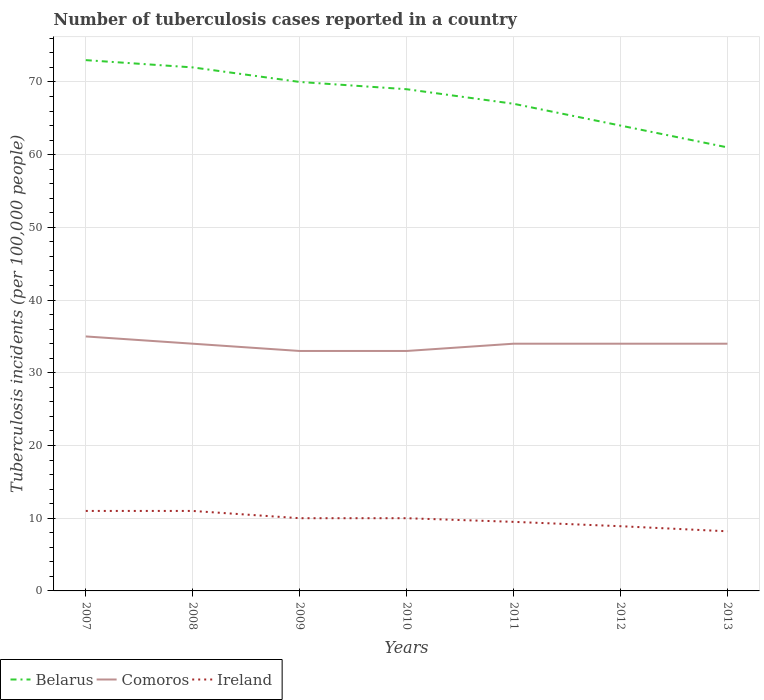Across all years, what is the maximum number of tuberculosis cases reported in in Belarus?
Ensure brevity in your answer.  61. What is the total number of tuberculosis cases reported in in Ireland in the graph?
Give a very brief answer. 2.1. What is the difference between the highest and the second highest number of tuberculosis cases reported in in Belarus?
Provide a succinct answer. 12. How many lines are there?
Provide a succinct answer. 3. How many years are there in the graph?
Make the answer very short. 7. What is the difference between two consecutive major ticks on the Y-axis?
Make the answer very short. 10. Are the values on the major ticks of Y-axis written in scientific E-notation?
Provide a succinct answer. No. Does the graph contain grids?
Keep it short and to the point. Yes. How are the legend labels stacked?
Offer a terse response. Horizontal. What is the title of the graph?
Your answer should be very brief. Number of tuberculosis cases reported in a country. What is the label or title of the Y-axis?
Your response must be concise. Tuberculosis incidents (per 100,0 people). What is the Tuberculosis incidents (per 100,000 people) of Ireland in 2007?
Your response must be concise. 11. What is the Tuberculosis incidents (per 100,000 people) in Ireland in 2008?
Your answer should be very brief. 11. What is the Tuberculosis incidents (per 100,000 people) in Belarus in 2009?
Keep it short and to the point. 70. What is the Tuberculosis incidents (per 100,000 people) of Comoros in 2011?
Make the answer very short. 34. What is the Tuberculosis incidents (per 100,000 people) in Ireland in 2012?
Provide a short and direct response. 8.9. What is the Tuberculosis incidents (per 100,000 people) in Comoros in 2013?
Offer a very short reply. 34. What is the Tuberculosis incidents (per 100,000 people) in Ireland in 2013?
Provide a succinct answer. 8.2. Across all years, what is the maximum Tuberculosis incidents (per 100,000 people) in Belarus?
Offer a terse response. 73. Across all years, what is the maximum Tuberculosis incidents (per 100,000 people) of Comoros?
Your answer should be compact. 35. Across all years, what is the minimum Tuberculosis incidents (per 100,000 people) of Comoros?
Offer a terse response. 33. What is the total Tuberculosis incidents (per 100,000 people) of Belarus in the graph?
Provide a short and direct response. 476. What is the total Tuberculosis incidents (per 100,000 people) in Comoros in the graph?
Keep it short and to the point. 237. What is the total Tuberculosis incidents (per 100,000 people) of Ireland in the graph?
Ensure brevity in your answer.  68.6. What is the difference between the Tuberculosis incidents (per 100,000 people) of Belarus in 2007 and that in 2008?
Keep it short and to the point. 1. What is the difference between the Tuberculosis incidents (per 100,000 people) of Ireland in 2007 and that in 2008?
Your answer should be compact. 0. What is the difference between the Tuberculosis incidents (per 100,000 people) of Belarus in 2007 and that in 2009?
Offer a terse response. 3. What is the difference between the Tuberculosis incidents (per 100,000 people) in Comoros in 2007 and that in 2009?
Your response must be concise. 2. What is the difference between the Tuberculosis incidents (per 100,000 people) in Ireland in 2007 and that in 2009?
Your answer should be very brief. 1. What is the difference between the Tuberculosis incidents (per 100,000 people) in Belarus in 2007 and that in 2010?
Your answer should be very brief. 4. What is the difference between the Tuberculosis incidents (per 100,000 people) of Comoros in 2007 and that in 2010?
Your answer should be compact. 2. What is the difference between the Tuberculosis incidents (per 100,000 people) of Comoros in 2007 and that in 2011?
Give a very brief answer. 1. What is the difference between the Tuberculosis incidents (per 100,000 people) of Ireland in 2007 and that in 2011?
Make the answer very short. 1.5. What is the difference between the Tuberculosis incidents (per 100,000 people) of Belarus in 2007 and that in 2012?
Provide a short and direct response. 9. What is the difference between the Tuberculosis incidents (per 100,000 people) of Belarus in 2007 and that in 2013?
Make the answer very short. 12. What is the difference between the Tuberculosis incidents (per 100,000 people) of Ireland in 2007 and that in 2013?
Keep it short and to the point. 2.8. What is the difference between the Tuberculosis incidents (per 100,000 people) of Comoros in 2008 and that in 2009?
Offer a terse response. 1. What is the difference between the Tuberculosis incidents (per 100,000 people) of Ireland in 2008 and that in 2009?
Give a very brief answer. 1. What is the difference between the Tuberculosis incidents (per 100,000 people) in Belarus in 2008 and that in 2010?
Provide a succinct answer. 3. What is the difference between the Tuberculosis incidents (per 100,000 people) of Comoros in 2008 and that in 2010?
Offer a terse response. 1. What is the difference between the Tuberculosis incidents (per 100,000 people) of Ireland in 2008 and that in 2011?
Your answer should be very brief. 1.5. What is the difference between the Tuberculosis incidents (per 100,000 people) in Belarus in 2008 and that in 2012?
Give a very brief answer. 8. What is the difference between the Tuberculosis incidents (per 100,000 people) in Belarus in 2008 and that in 2013?
Offer a very short reply. 11. What is the difference between the Tuberculosis incidents (per 100,000 people) in Ireland in 2008 and that in 2013?
Your response must be concise. 2.8. What is the difference between the Tuberculosis incidents (per 100,000 people) in Comoros in 2009 and that in 2010?
Provide a succinct answer. 0. What is the difference between the Tuberculosis incidents (per 100,000 people) in Belarus in 2009 and that in 2012?
Offer a terse response. 6. What is the difference between the Tuberculosis incidents (per 100,000 people) in Belarus in 2009 and that in 2013?
Your answer should be compact. 9. What is the difference between the Tuberculosis incidents (per 100,000 people) of Comoros in 2009 and that in 2013?
Offer a terse response. -1. What is the difference between the Tuberculosis incidents (per 100,000 people) in Ireland in 2009 and that in 2013?
Your answer should be compact. 1.8. What is the difference between the Tuberculosis incidents (per 100,000 people) of Belarus in 2010 and that in 2011?
Give a very brief answer. 2. What is the difference between the Tuberculosis incidents (per 100,000 people) in Comoros in 2010 and that in 2011?
Make the answer very short. -1. What is the difference between the Tuberculosis incidents (per 100,000 people) of Comoros in 2010 and that in 2012?
Your answer should be very brief. -1. What is the difference between the Tuberculosis incidents (per 100,000 people) in Comoros in 2011 and that in 2012?
Your answer should be compact. 0. What is the difference between the Tuberculosis incidents (per 100,000 people) in Ireland in 2011 and that in 2012?
Keep it short and to the point. 0.6. What is the difference between the Tuberculosis incidents (per 100,000 people) in Comoros in 2011 and that in 2013?
Give a very brief answer. 0. What is the difference between the Tuberculosis incidents (per 100,000 people) of Belarus in 2012 and that in 2013?
Provide a succinct answer. 3. What is the difference between the Tuberculosis incidents (per 100,000 people) in Ireland in 2012 and that in 2013?
Your answer should be very brief. 0.7. What is the difference between the Tuberculosis incidents (per 100,000 people) of Belarus in 2007 and the Tuberculosis incidents (per 100,000 people) of Comoros in 2008?
Make the answer very short. 39. What is the difference between the Tuberculosis incidents (per 100,000 people) of Comoros in 2007 and the Tuberculosis incidents (per 100,000 people) of Ireland in 2008?
Your answer should be very brief. 24. What is the difference between the Tuberculosis incidents (per 100,000 people) in Belarus in 2007 and the Tuberculosis incidents (per 100,000 people) in Comoros in 2009?
Ensure brevity in your answer.  40. What is the difference between the Tuberculosis incidents (per 100,000 people) in Comoros in 2007 and the Tuberculosis incidents (per 100,000 people) in Ireland in 2009?
Provide a succinct answer. 25. What is the difference between the Tuberculosis incidents (per 100,000 people) of Belarus in 2007 and the Tuberculosis incidents (per 100,000 people) of Comoros in 2010?
Offer a terse response. 40. What is the difference between the Tuberculosis incidents (per 100,000 people) of Comoros in 2007 and the Tuberculosis incidents (per 100,000 people) of Ireland in 2010?
Ensure brevity in your answer.  25. What is the difference between the Tuberculosis incidents (per 100,000 people) in Belarus in 2007 and the Tuberculosis incidents (per 100,000 people) in Ireland in 2011?
Your answer should be very brief. 63.5. What is the difference between the Tuberculosis incidents (per 100,000 people) of Belarus in 2007 and the Tuberculosis incidents (per 100,000 people) of Comoros in 2012?
Keep it short and to the point. 39. What is the difference between the Tuberculosis incidents (per 100,000 people) of Belarus in 2007 and the Tuberculosis incidents (per 100,000 people) of Ireland in 2012?
Your answer should be compact. 64.1. What is the difference between the Tuberculosis incidents (per 100,000 people) in Comoros in 2007 and the Tuberculosis incidents (per 100,000 people) in Ireland in 2012?
Ensure brevity in your answer.  26.1. What is the difference between the Tuberculosis incidents (per 100,000 people) of Belarus in 2007 and the Tuberculosis incidents (per 100,000 people) of Comoros in 2013?
Keep it short and to the point. 39. What is the difference between the Tuberculosis incidents (per 100,000 people) in Belarus in 2007 and the Tuberculosis incidents (per 100,000 people) in Ireland in 2013?
Provide a short and direct response. 64.8. What is the difference between the Tuberculosis incidents (per 100,000 people) in Comoros in 2007 and the Tuberculosis incidents (per 100,000 people) in Ireland in 2013?
Offer a very short reply. 26.8. What is the difference between the Tuberculosis incidents (per 100,000 people) in Belarus in 2008 and the Tuberculosis incidents (per 100,000 people) in Comoros in 2009?
Provide a short and direct response. 39. What is the difference between the Tuberculosis incidents (per 100,000 people) of Belarus in 2008 and the Tuberculosis incidents (per 100,000 people) of Ireland in 2009?
Give a very brief answer. 62. What is the difference between the Tuberculosis incidents (per 100,000 people) in Comoros in 2008 and the Tuberculosis incidents (per 100,000 people) in Ireland in 2009?
Give a very brief answer. 24. What is the difference between the Tuberculosis incidents (per 100,000 people) in Belarus in 2008 and the Tuberculosis incidents (per 100,000 people) in Ireland in 2010?
Your answer should be very brief. 62. What is the difference between the Tuberculosis incidents (per 100,000 people) of Comoros in 2008 and the Tuberculosis incidents (per 100,000 people) of Ireland in 2010?
Ensure brevity in your answer.  24. What is the difference between the Tuberculosis incidents (per 100,000 people) of Belarus in 2008 and the Tuberculosis incidents (per 100,000 people) of Ireland in 2011?
Keep it short and to the point. 62.5. What is the difference between the Tuberculosis incidents (per 100,000 people) of Comoros in 2008 and the Tuberculosis incidents (per 100,000 people) of Ireland in 2011?
Offer a terse response. 24.5. What is the difference between the Tuberculosis incidents (per 100,000 people) of Belarus in 2008 and the Tuberculosis incidents (per 100,000 people) of Comoros in 2012?
Your response must be concise. 38. What is the difference between the Tuberculosis incidents (per 100,000 people) in Belarus in 2008 and the Tuberculosis incidents (per 100,000 people) in Ireland in 2012?
Provide a succinct answer. 63.1. What is the difference between the Tuberculosis incidents (per 100,000 people) in Comoros in 2008 and the Tuberculosis incidents (per 100,000 people) in Ireland in 2012?
Provide a succinct answer. 25.1. What is the difference between the Tuberculosis incidents (per 100,000 people) of Belarus in 2008 and the Tuberculosis incidents (per 100,000 people) of Ireland in 2013?
Provide a succinct answer. 63.8. What is the difference between the Tuberculosis incidents (per 100,000 people) in Comoros in 2008 and the Tuberculosis incidents (per 100,000 people) in Ireland in 2013?
Make the answer very short. 25.8. What is the difference between the Tuberculosis incidents (per 100,000 people) of Belarus in 2009 and the Tuberculosis incidents (per 100,000 people) of Comoros in 2010?
Offer a very short reply. 37. What is the difference between the Tuberculosis incidents (per 100,000 people) in Belarus in 2009 and the Tuberculosis incidents (per 100,000 people) in Ireland in 2010?
Provide a short and direct response. 60. What is the difference between the Tuberculosis incidents (per 100,000 people) in Belarus in 2009 and the Tuberculosis incidents (per 100,000 people) in Ireland in 2011?
Provide a succinct answer. 60.5. What is the difference between the Tuberculosis incidents (per 100,000 people) of Comoros in 2009 and the Tuberculosis incidents (per 100,000 people) of Ireland in 2011?
Provide a succinct answer. 23.5. What is the difference between the Tuberculosis incidents (per 100,000 people) of Belarus in 2009 and the Tuberculosis incidents (per 100,000 people) of Ireland in 2012?
Provide a succinct answer. 61.1. What is the difference between the Tuberculosis incidents (per 100,000 people) in Comoros in 2009 and the Tuberculosis incidents (per 100,000 people) in Ireland in 2012?
Your response must be concise. 24.1. What is the difference between the Tuberculosis incidents (per 100,000 people) of Belarus in 2009 and the Tuberculosis incidents (per 100,000 people) of Ireland in 2013?
Make the answer very short. 61.8. What is the difference between the Tuberculosis incidents (per 100,000 people) in Comoros in 2009 and the Tuberculosis incidents (per 100,000 people) in Ireland in 2013?
Keep it short and to the point. 24.8. What is the difference between the Tuberculosis incidents (per 100,000 people) of Belarus in 2010 and the Tuberculosis incidents (per 100,000 people) of Comoros in 2011?
Provide a succinct answer. 35. What is the difference between the Tuberculosis incidents (per 100,000 people) of Belarus in 2010 and the Tuberculosis incidents (per 100,000 people) of Ireland in 2011?
Ensure brevity in your answer.  59.5. What is the difference between the Tuberculosis incidents (per 100,000 people) in Belarus in 2010 and the Tuberculosis incidents (per 100,000 people) in Comoros in 2012?
Ensure brevity in your answer.  35. What is the difference between the Tuberculosis incidents (per 100,000 people) in Belarus in 2010 and the Tuberculosis incidents (per 100,000 people) in Ireland in 2012?
Provide a succinct answer. 60.1. What is the difference between the Tuberculosis incidents (per 100,000 people) of Comoros in 2010 and the Tuberculosis incidents (per 100,000 people) of Ireland in 2012?
Your answer should be very brief. 24.1. What is the difference between the Tuberculosis incidents (per 100,000 people) in Belarus in 2010 and the Tuberculosis incidents (per 100,000 people) in Comoros in 2013?
Your answer should be compact. 35. What is the difference between the Tuberculosis incidents (per 100,000 people) of Belarus in 2010 and the Tuberculosis incidents (per 100,000 people) of Ireland in 2013?
Offer a very short reply. 60.8. What is the difference between the Tuberculosis incidents (per 100,000 people) of Comoros in 2010 and the Tuberculosis incidents (per 100,000 people) of Ireland in 2013?
Ensure brevity in your answer.  24.8. What is the difference between the Tuberculosis incidents (per 100,000 people) in Belarus in 2011 and the Tuberculosis incidents (per 100,000 people) in Ireland in 2012?
Provide a short and direct response. 58.1. What is the difference between the Tuberculosis incidents (per 100,000 people) in Comoros in 2011 and the Tuberculosis incidents (per 100,000 people) in Ireland in 2012?
Ensure brevity in your answer.  25.1. What is the difference between the Tuberculosis incidents (per 100,000 people) of Belarus in 2011 and the Tuberculosis incidents (per 100,000 people) of Comoros in 2013?
Keep it short and to the point. 33. What is the difference between the Tuberculosis incidents (per 100,000 people) of Belarus in 2011 and the Tuberculosis incidents (per 100,000 people) of Ireland in 2013?
Your answer should be very brief. 58.8. What is the difference between the Tuberculosis incidents (per 100,000 people) of Comoros in 2011 and the Tuberculosis incidents (per 100,000 people) of Ireland in 2013?
Provide a short and direct response. 25.8. What is the difference between the Tuberculosis incidents (per 100,000 people) of Belarus in 2012 and the Tuberculosis incidents (per 100,000 people) of Ireland in 2013?
Provide a succinct answer. 55.8. What is the difference between the Tuberculosis incidents (per 100,000 people) of Comoros in 2012 and the Tuberculosis incidents (per 100,000 people) of Ireland in 2013?
Provide a short and direct response. 25.8. What is the average Tuberculosis incidents (per 100,000 people) of Belarus per year?
Offer a terse response. 68. What is the average Tuberculosis incidents (per 100,000 people) in Comoros per year?
Make the answer very short. 33.86. In the year 2007, what is the difference between the Tuberculosis incidents (per 100,000 people) of Belarus and Tuberculosis incidents (per 100,000 people) of Comoros?
Offer a very short reply. 38. In the year 2008, what is the difference between the Tuberculosis incidents (per 100,000 people) of Belarus and Tuberculosis incidents (per 100,000 people) of Ireland?
Offer a terse response. 61. In the year 2009, what is the difference between the Tuberculosis incidents (per 100,000 people) in Comoros and Tuberculosis incidents (per 100,000 people) in Ireland?
Offer a terse response. 23. In the year 2010, what is the difference between the Tuberculosis incidents (per 100,000 people) of Belarus and Tuberculosis incidents (per 100,000 people) of Ireland?
Provide a short and direct response. 59. In the year 2010, what is the difference between the Tuberculosis incidents (per 100,000 people) in Comoros and Tuberculosis incidents (per 100,000 people) in Ireland?
Provide a succinct answer. 23. In the year 2011, what is the difference between the Tuberculosis incidents (per 100,000 people) of Belarus and Tuberculosis incidents (per 100,000 people) of Comoros?
Offer a very short reply. 33. In the year 2011, what is the difference between the Tuberculosis incidents (per 100,000 people) in Belarus and Tuberculosis incidents (per 100,000 people) in Ireland?
Ensure brevity in your answer.  57.5. In the year 2012, what is the difference between the Tuberculosis incidents (per 100,000 people) of Belarus and Tuberculosis incidents (per 100,000 people) of Comoros?
Keep it short and to the point. 30. In the year 2012, what is the difference between the Tuberculosis incidents (per 100,000 people) of Belarus and Tuberculosis incidents (per 100,000 people) of Ireland?
Offer a very short reply. 55.1. In the year 2012, what is the difference between the Tuberculosis incidents (per 100,000 people) of Comoros and Tuberculosis incidents (per 100,000 people) of Ireland?
Your response must be concise. 25.1. In the year 2013, what is the difference between the Tuberculosis incidents (per 100,000 people) in Belarus and Tuberculosis incidents (per 100,000 people) in Ireland?
Ensure brevity in your answer.  52.8. In the year 2013, what is the difference between the Tuberculosis incidents (per 100,000 people) in Comoros and Tuberculosis incidents (per 100,000 people) in Ireland?
Keep it short and to the point. 25.8. What is the ratio of the Tuberculosis incidents (per 100,000 people) in Belarus in 2007 to that in 2008?
Your answer should be compact. 1.01. What is the ratio of the Tuberculosis incidents (per 100,000 people) of Comoros in 2007 to that in 2008?
Provide a succinct answer. 1.03. What is the ratio of the Tuberculosis incidents (per 100,000 people) in Belarus in 2007 to that in 2009?
Your response must be concise. 1.04. What is the ratio of the Tuberculosis incidents (per 100,000 people) in Comoros in 2007 to that in 2009?
Make the answer very short. 1.06. What is the ratio of the Tuberculosis incidents (per 100,000 people) of Ireland in 2007 to that in 2009?
Make the answer very short. 1.1. What is the ratio of the Tuberculosis incidents (per 100,000 people) in Belarus in 2007 to that in 2010?
Keep it short and to the point. 1.06. What is the ratio of the Tuberculosis incidents (per 100,000 people) in Comoros in 2007 to that in 2010?
Ensure brevity in your answer.  1.06. What is the ratio of the Tuberculosis incidents (per 100,000 people) in Belarus in 2007 to that in 2011?
Ensure brevity in your answer.  1.09. What is the ratio of the Tuberculosis incidents (per 100,000 people) in Comoros in 2007 to that in 2011?
Your answer should be very brief. 1.03. What is the ratio of the Tuberculosis incidents (per 100,000 people) in Ireland in 2007 to that in 2011?
Give a very brief answer. 1.16. What is the ratio of the Tuberculosis incidents (per 100,000 people) of Belarus in 2007 to that in 2012?
Ensure brevity in your answer.  1.14. What is the ratio of the Tuberculosis incidents (per 100,000 people) in Comoros in 2007 to that in 2012?
Ensure brevity in your answer.  1.03. What is the ratio of the Tuberculosis incidents (per 100,000 people) of Ireland in 2007 to that in 2012?
Make the answer very short. 1.24. What is the ratio of the Tuberculosis incidents (per 100,000 people) of Belarus in 2007 to that in 2013?
Give a very brief answer. 1.2. What is the ratio of the Tuberculosis incidents (per 100,000 people) of Comoros in 2007 to that in 2013?
Provide a short and direct response. 1.03. What is the ratio of the Tuberculosis incidents (per 100,000 people) in Ireland in 2007 to that in 2013?
Provide a short and direct response. 1.34. What is the ratio of the Tuberculosis incidents (per 100,000 people) of Belarus in 2008 to that in 2009?
Provide a short and direct response. 1.03. What is the ratio of the Tuberculosis incidents (per 100,000 people) of Comoros in 2008 to that in 2009?
Ensure brevity in your answer.  1.03. What is the ratio of the Tuberculosis incidents (per 100,000 people) of Belarus in 2008 to that in 2010?
Give a very brief answer. 1.04. What is the ratio of the Tuberculosis incidents (per 100,000 people) of Comoros in 2008 to that in 2010?
Make the answer very short. 1.03. What is the ratio of the Tuberculosis incidents (per 100,000 people) of Belarus in 2008 to that in 2011?
Offer a terse response. 1.07. What is the ratio of the Tuberculosis incidents (per 100,000 people) in Ireland in 2008 to that in 2011?
Ensure brevity in your answer.  1.16. What is the ratio of the Tuberculosis incidents (per 100,000 people) in Belarus in 2008 to that in 2012?
Your answer should be very brief. 1.12. What is the ratio of the Tuberculosis incidents (per 100,000 people) of Comoros in 2008 to that in 2012?
Make the answer very short. 1. What is the ratio of the Tuberculosis incidents (per 100,000 people) in Ireland in 2008 to that in 2012?
Your answer should be very brief. 1.24. What is the ratio of the Tuberculosis incidents (per 100,000 people) of Belarus in 2008 to that in 2013?
Give a very brief answer. 1.18. What is the ratio of the Tuberculosis incidents (per 100,000 people) in Comoros in 2008 to that in 2013?
Provide a succinct answer. 1. What is the ratio of the Tuberculosis incidents (per 100,000 people) of Ireland in 2008 to that in 2013?
Make the answer very short. 1.34. What is the ratio of the Tuberculosis incidents (per 100,000 people) in Belarus in 2009 to that in 2010?
Your response must be concise. 1.01. What is the ratio of the Tuberculosis incidents (per 100,000 people) of Comoros in 2009 to that in 2010?
Give a very brief answer. 1. What is the ratio of the Tuberculosis incidents (per 100,000 people) of Belarus in 2009 to that in 2011?
Provide a succinct answer. 1.04. What is the ratio of the Tuberculosis incidents (per 100,000 people) of Comoros in 2009 to that in 2011?
Offer a terse response. 0.97. What is the ratio of the Tuberculosis incidents (per 100,000 people) of Ireland in 2009 to that in 2011?
Your response must be concise. 1.05. What is the ratio of the Tuberculosis incidents (per 100,000 people) of Belarus in 2009 to that in 2012?
Offer a very short reply. 1.09. What is the ratio of the Tuberculosis incidents (per 100,000 people) of Comoros in 2009 to that in 2012?
Keep it short and to the point. 0.97. What is the ratio of the Tuberculosis incidents (per 100,000 people) in Ireland in 2009 to that in 2012?
Make the answer very short. 1.12. What is the ratio of the Tuberculosis incidents (per 100,000 people) of Belarus in 2009 to that in 2013?
Provide a succinct answer. 1.15. What is the ratio of the Tuberculosis incidents (per 100,000 people) in Comoros in 2009 to that in 2013?
Provide a succinct answer. 0.97. What is the ratio of the Tuberculosis incidents (per 100,000 people) of Ireland in 2009 to that in 2013?
Give a very brief answer. 1.22. What is the ratio of the Tuberculosis incidents (per 100,000 people) of Belarus in 2010 to that in 2011?
Your answer should be compact. 1.03. What is the ratio of the Tuberculosis incidents (per 100,000 people) in Comoros in 2010 to that in 2011?
Your response must be concise. 0.97. What is the ratio of the Tuberculosis incidents (per 100,000 people) in Ireland in 2010 to that in 2011?
Your response must be concise. 1.05. What is the ratio of the Tuberculosis incidents (per 100,000 people) in Belarus in 2010 to that in 2012?
Keep it short and to the point. 1.08. What is the ratio of the Tuberculosis incidents (per 100,000 people) of Comoros in 2010 to that in 2012?
Give a very brief answer. 0.97. What is the ratio of the Tuberculosis incidents (per 100,000 people) in Ireland in 2010 to that in 2012?
Your response must be concise. 1.12. What is the ratio of the Tuberculosis incidents (per 100,000 people) of Belarus in 2010 to that in 2013?
Make the answer very short. 1.13. What is the ratio of the Tuberculosis incidents (per 100,000 people) of Comoros in 2010 to that in 2013?
Keep it short and to the point. 0.97. What is the ratio of the Tuberculosis incidents (per 100,000 people) of Ireland in 2010 to that in 2013?
Provide a short and direct response. 1.22. What is the ratio of the Tuberculosis incidents (per 100,000 people) in Belarus in 2011 to that in 2012?
Give a very brief answer. 1.05. What is the ratio of the Tuberculosis incidents (per 100,000 people) in Comoros in 2011 to that in 2012?
Offer a terse response. 1. What is the ratio of the Tuberculosis incidents (per 100,000 people) in Ireland in 2011 to that in 2012?
Make the answer very short. 1.07. What is the ratio of the Tuberculosis incidents (per 100,000 people) of Belarus in 2011 to that in 2013?
Ensure brevity in your answer.  1.1. What is the ratio of the Tuberculosis incidents (per 100,000 people) in Comoros in 2011 to that in 2013?
Ensure brevity in your answer.  1. What is the ratio of the Tuberculosis incidents (per 100,000 people) of Ireland in 2011 to that in 2013?
Ensure brevity in your answer.  1.16. What is the ratio of the Tuberculosis incidents (per 100,000 people) in Belarus in 2012 to that in 2013?
Give a very brief answer. 1.05. What is the ratio of the Tuberculosis incidents (per 100,000 people) of Comoros in 2012 to that in 2013?
Give a very brief answer. 1. What is the ratio of the Tuberculosis incidents (per 100,000 people) of Ireland in 2012 to that in 2013?
Ensure brevity in your answer.  1.09. What is the difference between the highest and the second highest Tuberculosis incidents (per 100,000 people) of Belarus?
Make the answer very short. 1. What is the difference between the highest and the lowest Tuberculosis incidents (per 100,000 people) in Belarus?
Make the answer very short. 12. 